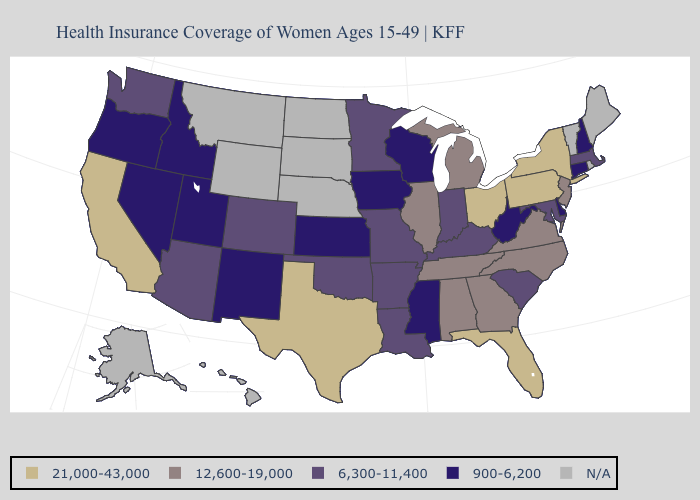What is the value of Connecticut?
Write a very short answer. 900-6,200. Among the states that border Colorado , which have the lowest value?
Concise answer only. Kansas, New Mexico, Utah. Does the map have missing data?
Write a very short answer. Yes. What is the highest value in the USA?
Keep it brief. 21,000-43,000. Which states have the highest value in the USA?
Concise answer only. California, Florida, New York, Ohio, Pennsylvania, Texas. Name the states that have a value in the range 12,600-19,000?
Write a very short answer. Alabama, Georgia, Illinois, Michigan, New Jersey, North Carolina, Tennessee, Virginia. What is the highest value in states that border Virginia?
Write a very short answer. 12,600-19,000. Name the states that have a value in the range 900-6,200?
Give a very brief answer. Connecticut, Delaware, Idaho, Iowa, Kansas, Mississippi, Nevada, New Hampshire, New Mexico, Oregon, Utah, West Virginia, Wisconsin. Does Ohio have the highest value in the MidWest?
Be succinct. Yes. What is the value of Maryland?
Give a very brief answer. 6,300-11,400. What is the value of Nevada?
Give a very brief answer. 900-6,200. 